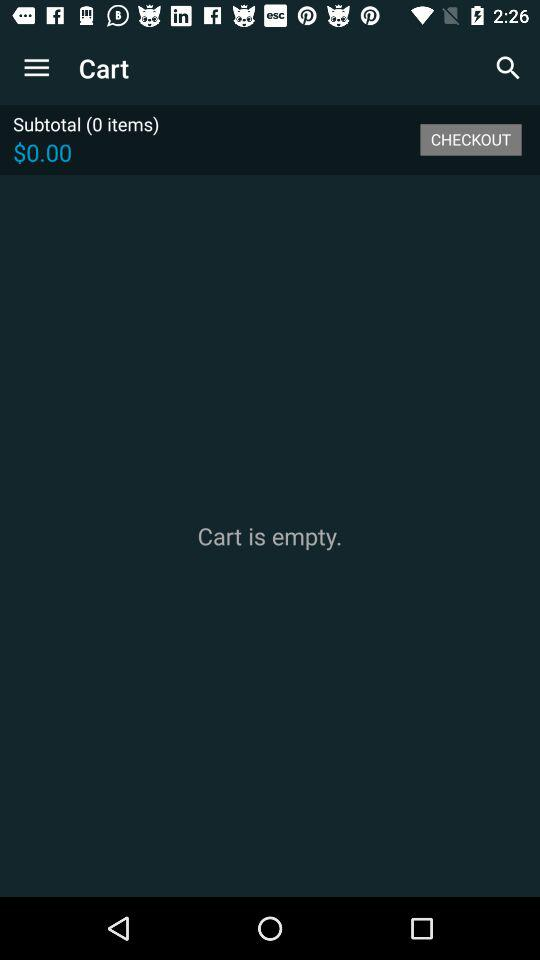How many items are in the cart?
Answer the question using a single word or phrase. 0 